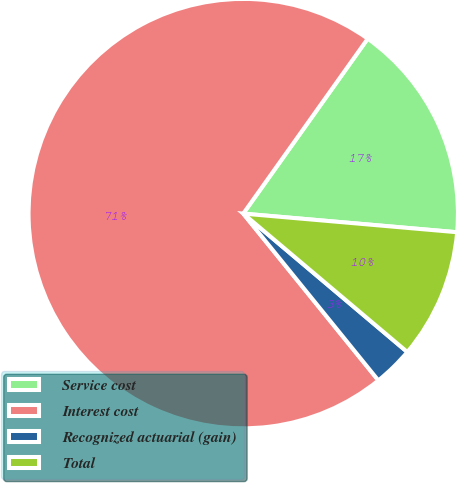<chart> <loc_0><loc_0><loc_500><loc_500><pie_chart><fcel>Service cost<fcel>Interest cost<fcel>Recognized actuarial (gain)<fcel>Total<nl><fcel>16.54%<fcel>70.68%<fcel>3.01%<fcel>9.77%<nl></chart> 